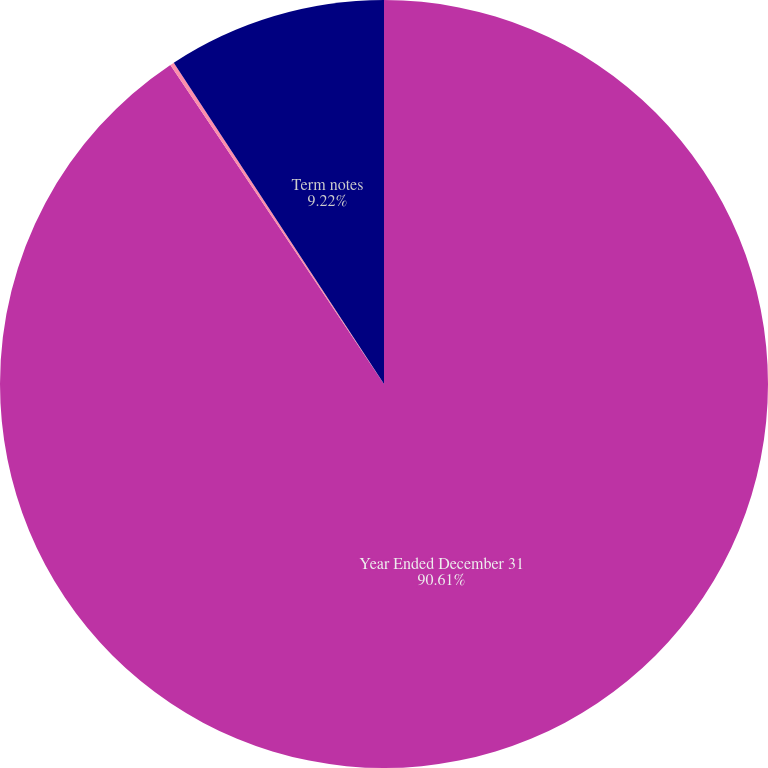Convert chart. <chart><loc_0><loc_0><loc_500><loc_500><pie_chart><fcel>Year Ended December 31<fcel>Interest-rate swaps<fcel>Term notes<nl><fcel>90.61%<fcel>0.17%<fcel>9.22%<nl></chart> 